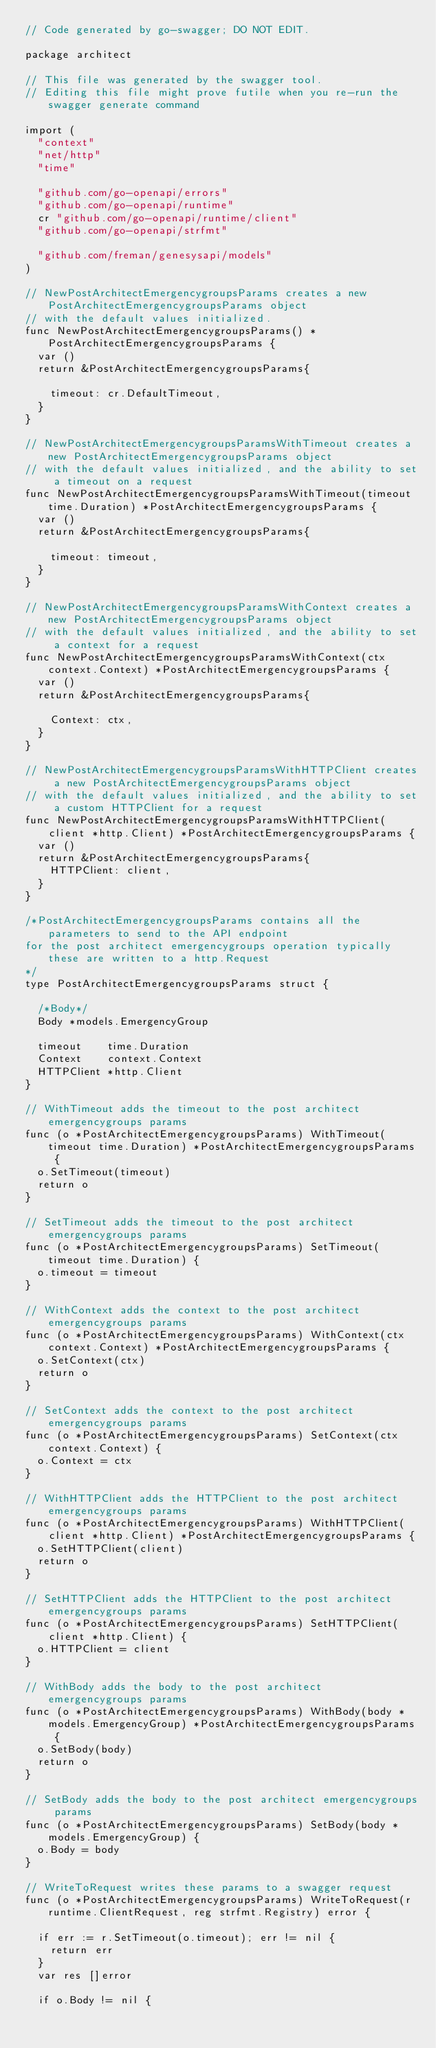<code> <loc_0><loc_0><loc_500><loc_500><_Go_>// Code generated by go-swagger; DO NOT EDIT.

package architect

// This file was generated by the swagger tool.
// Editing this file might prove futile when you re-run the swagger generate command

import (
	"context"
	"net/http"
	"time"

	"github.com/go-openapi/errors"
	"github.com/go-openapi/runtime"
	cr "github.com/go-openapi/runtime/client"
	"github.com/go-openapi/strfmt"

	"github.com/freman/genesysapi/models"
)

// NewPostArchitectEmergencygroupsParams creates a new PostArchitectEmergencygroupsParams object
// with the default values initialized.
func NewPostArchitectEmergencygroupsParams() *PostArchitectEmergencygroupsParams {
	var ()
	return &PostArchitectEmergencygroupsParams{

		timeout: cr.DefaultTimeout,
	}
}

// NewPostArchitectEmergencygroupsParamsWithTimeout creates a new PostArchitectEmergencygroupsParams object
// with the default values initialized, and the ability to set a timeout on a request
func NewPostArchitectEmergencygroupsParamsWithTimeout(timeout time.Duration) *PostArchitectEmergencygroupsParams {
	var ()
	return &PostArchitectEmergencygroupsParams{

		timeout: timeout,
	}
}

// NewPostArchitectEmergencygroupsParamsWithContext creates a new PostArchitectEmergencygroupsParams object
// with the default values initialized, and the ability to set a context for a request
func NewPostArchitectEmergencygroupsParamsWithContext(ctx context.Context) *PostArchitectEmergencygroupsParams {
	var ()
	return &PostArchitectEmergencygroupsParams{

		Context: ctx,
	}
}

// NewPostArchitectEmergencygroupsParamsWithHTTPClient creates a new PostArchitectEmergencygroupsParams object
// with the default values initialized, and the ability to set a custom HTTPClient for a request
func NewPostArchitectEmergencygroupsParamsWithHTTPClient(client *http.Client) *PostArchitectEmergencygroupsParams {
	var ()
	return &PostArchitectEmergencygroupsParams{
		HTTPClient: client,
	}
}

/*PostArchitectEmergencygroupsParams contains all the parameters to send to the API endpoint
for the post architect emergencygroups operation typically these are written to a http.Request
*/
type PostArchitectEmergencygroupsParams struct {

	/*Body*/
	Body *models.EmergencyGroup

	timeout    time.Duration
	Context    context.Context
	HTTPClient *http.Client
}

// WithTimeout adds the timeout to the post architect emergencygroups params
func (o *PostArchitectEmergencygroupsParams) WithTimeout(timeout time.Duration) *PostArchitectEmergencygroupsParams {
	o.SetTimeout(timeout)
	return o
}

// SetTimeout adds the timeout to the post architect emergencygroups params
func (o *PostArchitectEmergencygroupsParams) SetTimeout(timeout time.Duration) {
	o.timeout = timeout
}

// WithContext adds the context to the post architect emergencygroups params
func (o *PostArchitectEmergencygroupsParams) WithContext(ctx context.Context) *PostArchitectEmergencygroupsParams {
	o.SetContext(ctx)
	return o
}

// SetContext adds the context to the post architect emergencygroups params
func (o *PostArchitectEmergencygroupsParams) SetContext(ctx context.Context) {
	o.Context = ctx
}

// WithHTTPClient adds the HTTPClient to the post architect emergencygroups params
func (o *PostArchitectEmergencygroupsParams) WithHTTPClient(client *http.Client) *PostArchitectEmergencygroupsParams {
	o.SetHTTPClient(client)
	return o
}

// SetHTTPClient adds the HTTPClient to the post architect emergencygroups params
func (o *PostArchitectEmergencygroupsParams) SetHTTPClient(client *http.Client) {
	o.HTTPClient = client
}

// WithBody adds the body to the post architect emergencygroups params
func (o *PostArchitectEmergencygroupsParams) WithBody(body *models.EmergencyGroup) *PostArchitectEmergencygroupsParams {
	o.SetBody(body)
	return o
}

// SetBody adds the body to the post architect emergencygroups params
func (o *PostArchitectEmergencygroupsParams) SetBody(body *models.EmergencyGroup) {
	o.Body = body
}

// WriteToRequest writes these params to a swagger request
func (o *PostArchitectEmergencygroupsParams) WriteToRequest(r runtime.ClientRequest, reg strfmt.Registry) error {

	if err := r.SetTimeout(o.timeout); err != nil {
		return err
	}
	var res []error

	if o.Body != nil {</code> 